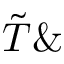Convert formula to latex. <formula><loc_0><loc_0><loc_500><loc_500>\tilde { T } \&</formula> 